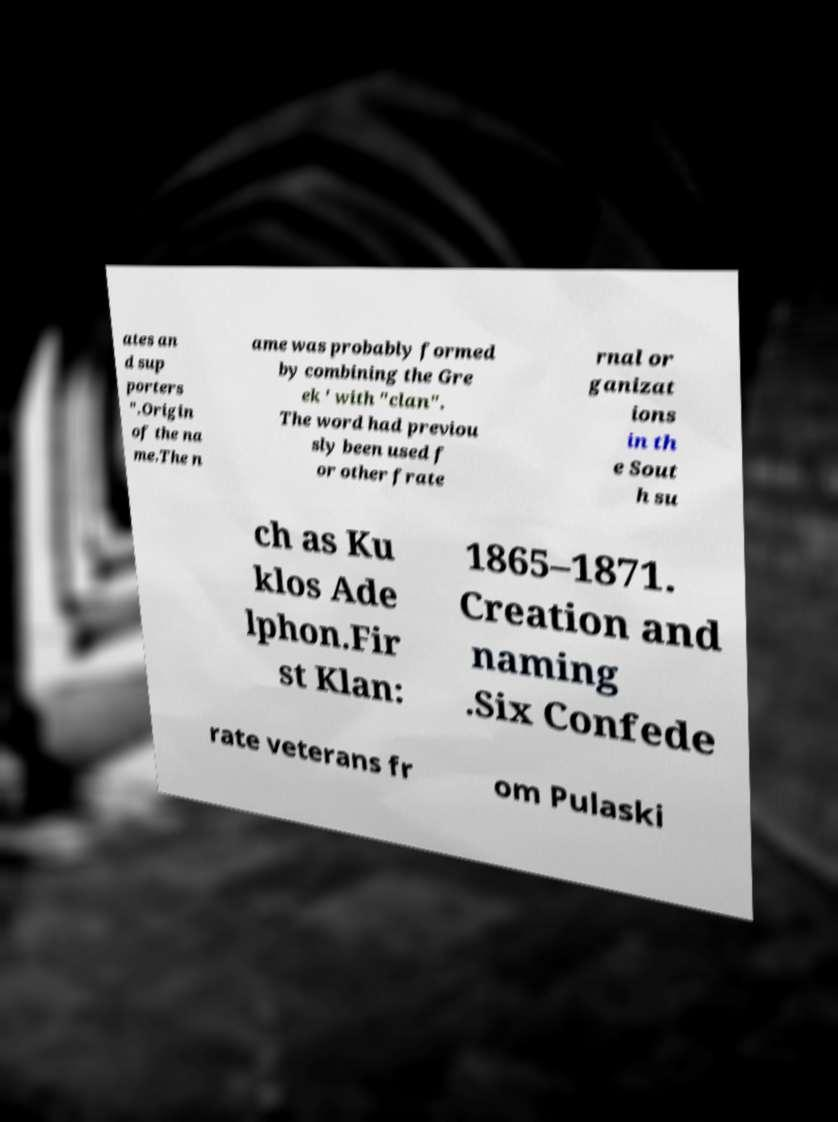For documentation purposes, I need the text within this image transcribed. Could you provide that? ates an d sup porters ".Origin of the na me.The n ame was probably formed by combining the Gre ek ' with "clan". The word had previou sly been used f or other frate rnal or ganizat ions in th e Sout h su ch as Ku klos Ade lphon.Fir st Klan: 1865–1871. Creation and naming .Six Confede rate veterans fr om Pulaski 